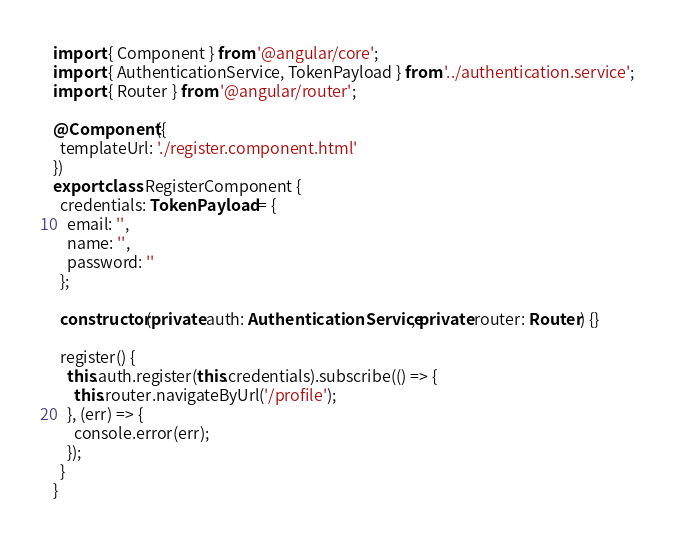Convert code to text. <code><loc_0><loc_0><loc_500><loc_500><_TypeScript_>import { Component } from '@angular/core';
import { AuthenticationService, TokenPayload } from '../authentication.service';
import { Router } from '@angular/router';

@Component({
  templateUrl: './register.component.html'
})
export class RegisterComponent {
  credentials: TokenPayload = {
    email: '',
    name: '',
    password: ''
  };

  constructor(private auth: AuthenticationService, private router: Router) {}

  register() {
    this.auth.register(this.credentials).subscribe(() => {
      this.router.navigateByUrl('/profile');
    }, (err) => {
      console.error(err);
    });
  }
}
</code> 